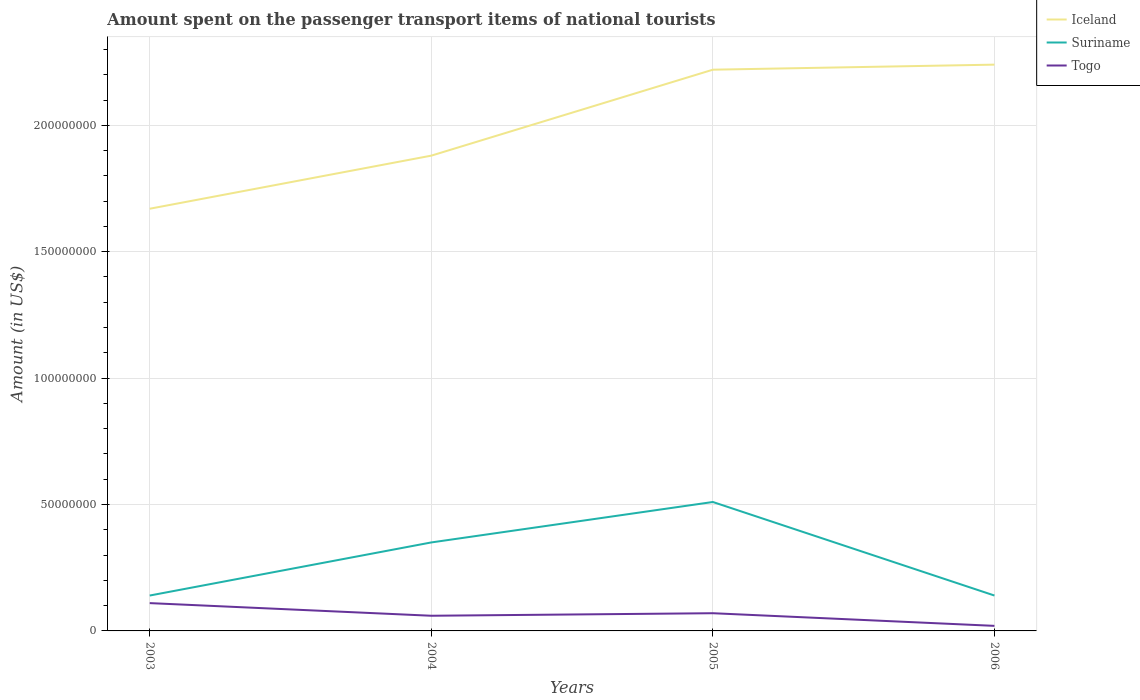How many different coloured lines are there?
Ensure brevity in your answer.  3. Across all years, what is the maximum amount spent on the passenger transport items of national tourists in Suriname?
Provide a succinct answer. 1.40e+07. What is the total amount spent on the passenger transport items of national tourists in Suriname in the graph?
Offer a very short reply. -1.60e+07. What is the difference between the highest and the second highest amount spent on the passenger transport items of national tourists in Iceland?
Your response must be concise. 5.70e+07. Is the amount spent on the passenger transport items of national tourists in Iceland strictly greater than the amount spent on the passenger transport items of national tourists in Togo over the years?
Keep it short and to the point. No. How many years are there in the graph?
Make the answer very short. 4. Where does the legend appear in the graph?
Offer a terse response. Top right. How many legend labels are there?
Give a very brief answer. 3. What is the title of the graph?
Your response must be concise. Amount spent on the passenger transport items of national tourists. What is the label or title of the X-axis?
Ensure brevity in your answer.  Years. What is the Amount (in US$) in Iceland in 2003?
Ensure brevity in your answer.  1.67e+08. What is the Amount (in US$) in Suriname in 2003?
Offer a terse response. 1.40e+07. What is the Amount (in US$) of Togo in 2003?
Your answer should be compact. 1.10e+07. What is the Amount (in US$) of Iceland in 2004?
Offer a terse response. 1.88e+08. What is the Amount (in US$) of Suriname in 2004?
Make the answer very short. 3.50e+07. What is the Amount (in US$) of Togo in 2004?
Provide a short and direct response. 6.00e+06. What is the Amount (in US$) of Iceland in 2005?
Your answer should be compact. 2.22e+08. What is the Amount (in US$) of Suriname in 2005?
Provide a short and direct response. 5.10e+07. What is the Amount (in US$) of Togo in 2005?
Your answer should be very brief. 7.00e+06. What is the Amount (in US$) of Iceland in 2006?
Keep it short and to the point. 2.24e+08. What is the Amount (in US$) of Suriname in 2006?
Give a very brief answer. 1.40e+07. Across all years, what is the maximum Amount (in US$) of Iceland?
Offer a terse response. 2.24e+08. Across all years, what is the maximum Amount (in US$) of Suriname?
Offer a terse response. 5.10e+07. Across all years, what is the maximum Amount (in US$) in Togo?
Ensure brevity in your answer.  1.10e+07. Across all years, what is the minimum Amount (in US$) of Iceland?
Ensure brevity in your answer.  1.67e+08. Across all years, what is the minimum Amount (in US$) in Suriname?
Give a very brief answer. 1.40e+07. What is the total Amount (in US$) in Iceland in the graph?
Your response must be concise. 8.01e+08. What is the total Amount (in US$) in Suriname in the graph?
Offer a very short reply. 1.14e+08. What is the total Amount (in US$) in Togo in the graph?
Provide a short and direct response. 2.60e+07. What is the difference between the Amount (in US$) in Iceland in 2003 and that in 2004?
Give a very brief answer. -2.10e+07. What is the difference between the Amount (in US$) of Suriname in 2003 and that in 2004?
Offer a very short reply. -2.10e+07. What is the difference between the Amount (in US$) of Iceland in 2003 and that in 2005?
Provide a short and direct response. -5.50e+07. What is the difference between the Amount (in US$) in Suriname in 2003 and that in 2005?
Keep it short and to the point. -3.70e+07. What is the difference between the Amount (in US$) of Togo in 2003 and that in 2005?
Your answer should be very brief. 4.00e+06. What is the difference between the Amount (in US$) of Iceland in 2003 and that in 2006?
Keep it short and to the point. -5.70e+07. What is the difference between the Amount (in US$) in Togo in 2003 and that in 2006?
Ensure brevity in your answer.  9.00e+06. What is the difference between the Amount (in US$) in Iceland in 2004 and that in 2005?
Your answer should be very brief. -3.40e+07. What is the difference between the Amount (in US$) of Suriname in 2004 and that in 2005?
Provide a short and direct response. -1.60e+07. What is the difference between the Amount (in US$) in Togo in 2004 and that in 2005?
Offer a terse response. -1.00e+06. What is the difference between the Amount (in US$) in Iceland in 2004 and that in 2006?
Your answer should be compact. -3.60e+07. What is the difference between the Amount (in US$) in Suriname in 2004 and that in 2006?
Provide a short and direct response. 2.10e+07. What is the difference between the Amount (in US$) of Suriname in 2005 and that in 2006?
Make the answer very short. 3.70e+07. What is the difference between the Amount (in US$) in Iceland in 2003 and the Amount (in US$) in Suriname in 2004?
Make the answer very short. 1.32e+08. What is the difference between the Amount (in US$) of Iceland in 2003 and the Amount (in US$) of Togo in 2004?
Make the answer very short. 1.61e+08. What is the difference between the Amount (in US$) of Suriname in 2003 and the Amount (in US$) of Togo in 2004?
Your response must be concise. 8.00e+06. What is the difference between the Amount (in US$) of Iceland in 2003 and the Amount (in US$) of Suriname in 2005?
Provide a short and direct response. 1.16e+08. What is the difference between the Amount (in US$) in Iceland in 2003 and the Amount (in US$) in Togo in 2005?
Your answer should be compact. 1.60e+08. What is the difference between the Amount (in US$) of Iceland in 2003 and the Amount (in US$) of Suriname in 2006?
Offer a very short reply. 1.53e+08. What is the difference between the Amount (in US$) in Iceland in 2003 and the Amount (in US$) in Togo in 2006?
Give a very brief answer. 1.65e+08. What is the difference between the Amount (in US$) in Suriname in 2003 and the Amount (in US$) in Togo in 2006?
Give a very brief answer. 1.20e+07. What is the difference between the Amount (in US$) in Iceland in 2004 and the Amount (in US$) in Suriname in 2005?
Make the answer very short. 1.37e+08. What is the difference between the Amount (in US$) of Iceland in 2004 and the Amount (in US$) of Togo in 2005?
Keep it short and to the point. 1.81e+08. What is the difference between the Amount (in US$) of Suriname in 2004 and the Amount (in US$) of Togo in 2005?
Offer a very short reply. 2.80e+07. What is the difference between the Amount (in US$) of Iceland in 2004 and the Amount (in US$) of Suriname in 2006?
Keep it short and to the point. 1.74e+08. What is the difference between the Amount (in US$) of Iceland in 2004 and the Amount (in US$) of Togo in 2006?
Your answer should be compact. 1.86e+08. What is the difference between the Amount (in US$) in Suriname in 2004 and the Amount (in US$) in Togo in 2006?
Ensure brevity in your answer.  3.30e+07. What is the difference between the Amount (in US$) in Iceland in 2005 and the Amount (in US$) in Suriname in 2006?
Your answer should be compact. 2.08e+08. What is the difference between the Amount (in US$) of Iceland in 2005 and the Amount (in US$) of Togo in 2006?
Offer a very short reply. 2.20e+08. What is the difference between the Amount (in US$) in Suriname in 2005 and the Amount (in US$) in Togo in 2006?
Offer a very short reply. 4.90e+07. What is the average Amount (in US$) in Iceland per year?
Keep it short and to the point. 2.00e+08. What is the average Amount (in US$) of Suriname per year?
Provide a succinct answer. 2.85e+07. What is the average Amount (in US$) in Togo per year?
Your answer should be compact. 6.50e+06. In the year 2003, what is the difference between the Amount (in US$) in Iceland and Amount (in US$) in Suriname?
Your answer should be compact. 1.53e+08. In the year 2003, what is the difference between the Amount (in US$) of Iceland and Amount (in US$) of Togo?
Make the answer very short. 1.56e+08. In the year 2003, what is the difference between the Amount (in US$) of Suriname and Amount (in US$) of Togo?
Provide a short and direct response. 3.00e+06. In the year 2004, what is the difference between the Amount (in US$) in Iceland and Amount (in US$) in Suriname?
Your response must be concise. 1.53e+08. In the year 2004, what is the difference between the Amount (in US$) of Iceland and Amount (in US$) of Togo?
Provide a succinct answer. 1.82e+08. In the year 2004, what is the difference between the Amount (in US$) of Suriname and Amount (in US$) of Togo?
Offer a terse response. 2.90e+07. In the year 2005, what is the difference between the Amount (in US$) in Iceland and Amount (in US$) in Suriname?
Offer a terse response. 1.71e+08. In the year 2005, what is the difference between the Amount (in US$) in Iceland and Amount (in US$) in Togo?
Your response must be concise. 2.15e+08. In the year 2005, what is the difference between the Amount (in US$) in Suriname and Amount (in US$) in Togo?
Your answer should be compact. 4.40e+07. In the year 2006, what is the difference between the Amount (in US$) in Iceland and Amount (in US$) in Suriname?
Provide a short and direct response. 2.10e+08. In the year 2006, what is the difference between the Amount (in US$) of Iceland and Amount (in US$) of Togo?
Provide a short and direct response. 2.22e+08. In the year 2006, what is the difference between the Amount (in US$) of Suriname and Amount (in US$) of Togo?
Give a very brief answer. 1.20e+07. What is the ratio of the Amount (in US$) of Iceland in 2003 to that in 2004?
Offer a very short reply. 0.89. What is the ratio of the Amount (in US$) of Togo in 2003 to that in 2004?
Your answer should be compact. 1.83. What is the ratio of the Amount (in US$) in Iceland in 2003 to that in 2005?
Your response must be concise. 0.75. What is the ratio of the Amount (in US$) of Suriname in 2003 to that in 2005?
Make the answer very short. 0.27. What is the ratio of the Amount (in US$) of Togo in 2003 to that in 2005?
Offer a terse response. 1.57. What is the ratio of the Amount (in US$) in Iceland in 2003 to that in 2006?
Provide a short and direct response. 0.75. What is the ratio of the Amount (in US$) of Suriname in 2003 to that in 2006?
Give a very brief answer. 1. What is the ratio of the Amount (in US$) in Iceland in 2004 to that in 2005?
Offer a terse response. 0.85. What is the ratio of the Amount (in US$) in Suriname in 2004 to that in 2005?
Give a very brief answer. 0.69. What is the ratio of the Amount (in US$) in Iceland in 2004 to that in 2006?
Your response must be concise. 0.84. What is the ratio of the Amount (in US$) in Iceland in 2005 to that in 2006?
Give a very brief answer. 0.99. What is the ratio of the Amount (in US$) of Suriname in 2005 to that in 2006?
Make the answer very short. 3.64. What is the ratio of the Amount (in US$) of Togo in 2005 to that in 2006?
Keep it short and to the point. 3.5. What is the difference between the highest and the second highest Amount (in US$) of Iceland?
Ensure brevity in your answer.  2.00e+06. What is the difference between the highest and the second highest Amount (in US$) of Suriname?
Keep it short and to the point. 1.60e+07. What is the difference between the highest and the second highest Amount (in US$) of Togo?
Give a very brief answer. 4.00e+06. What is the difference between the highest and the lowest Amount (in US$) in Iceland?
Offer a terse response. 5.70e+07. What is the difference between the highest and the lowest Amount (in US$) of Suriname?
Offer a terse response. 3.70e+07. What is the difference between the highest and the lowest Amount (in US$) in Togo?
Keep it short and to the point. 9.00e+06. 